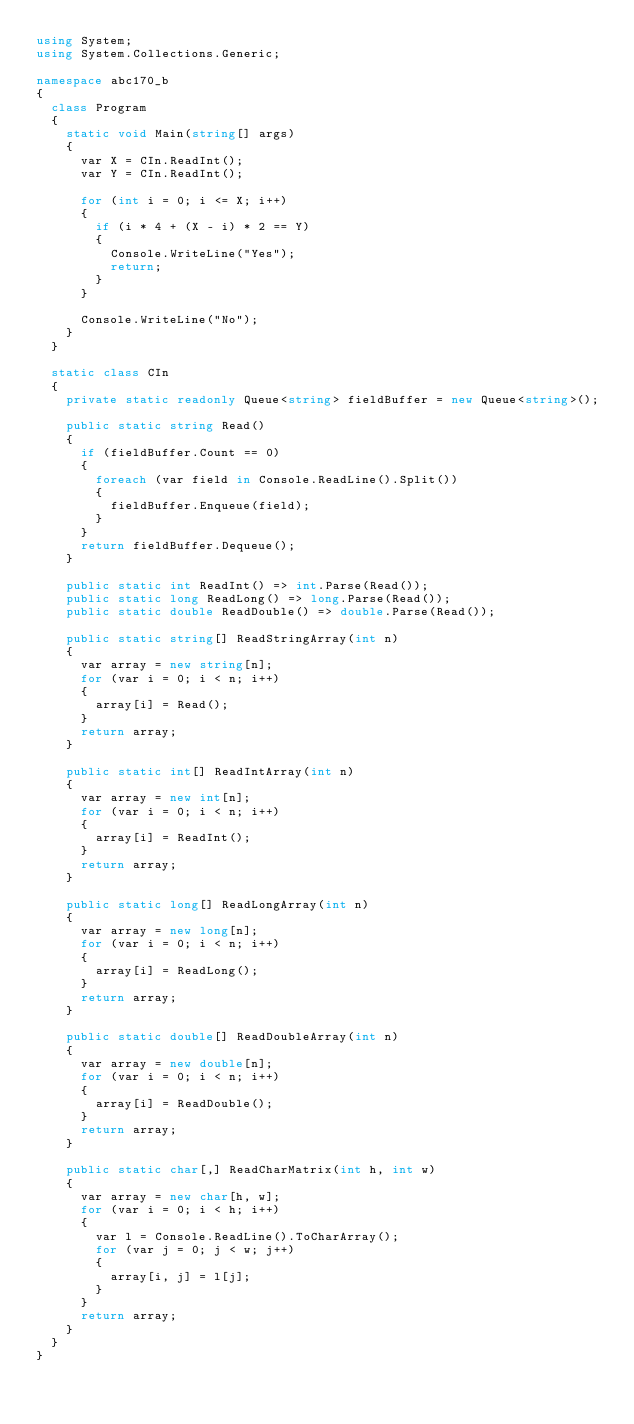Convert code to text. <code><loc_0><loc_0><loc_500><loc_500><_C#_>using System;
using System.Collections.Generic;

namespace abc170_b
{
  class Program
  {
    static void Main(string[] args)
    {
      var X = CIn.ReadInt();
      var Y = CIn.ReadInt();

      for (int i = 0; i <= X; i++)
      {
        if (i * 4 + (X - i) * 2 == Y)
        {
          Console.WriteLine("Yes");
          return;
        }
      }

      Console.WriteLine("No");
    }
  }

  static class CIn
  {
    private static readonly Queue<string> fieldBuffer = new Queue<string>();

    public static string Read()
    {
      if (fieldBuffer.Count == 0)
      {
        foreach (var field in Console.ReadLine().Split())
        {
          fieldBuffer.Enqueue(field);
        }
      }
      return fieldBuffer.Dequeue();
    }

    public static int ReadInt() => int.Parse(Read());
    public static long ReadLong() => long.Parse(Read());
    public static double ReadDouble() => double.Parse(Read());

    public static string[] ReadStringArray(int n)
    {
      var array = new string[n];
      for (var i = 0; i < n; i++)
      {
        array[i] = Read();
      }
      return array;
    }

    public static int[] ReadIntArray(int n)
    {
      var array = new int[n];
      for (var i = 0; i < n; i++)
      {
        array[i] = ReadInt();
      }
      return array;
    }

    public static long[] ReadLongArray(int n)
    {
      var array = new long[n];
      for (var i = 0; i < n; i++)
      {
        array[i] = ReadLong();
      }
      return array;
    }

    public static double[] ReadDoubleArray(int n)
    {
      var array = new double[n];
      for (var i = 0; i < n; i++)
      {
        array[i] = ReadDouble();
      }
      return array;
    }

    public static char[,] ReadCharMatrix(int h, int w)
    {
      var array = new char[h, w];
      for (var i = 0; i < h; i++)
      {
        var l = Console.ReadLine().ToCharArray();
        for (var j = 0; j < w; j++)
        {
          array[i, j] = l[j];
        }
      }
      return array;
    }
  }
}
</code> 